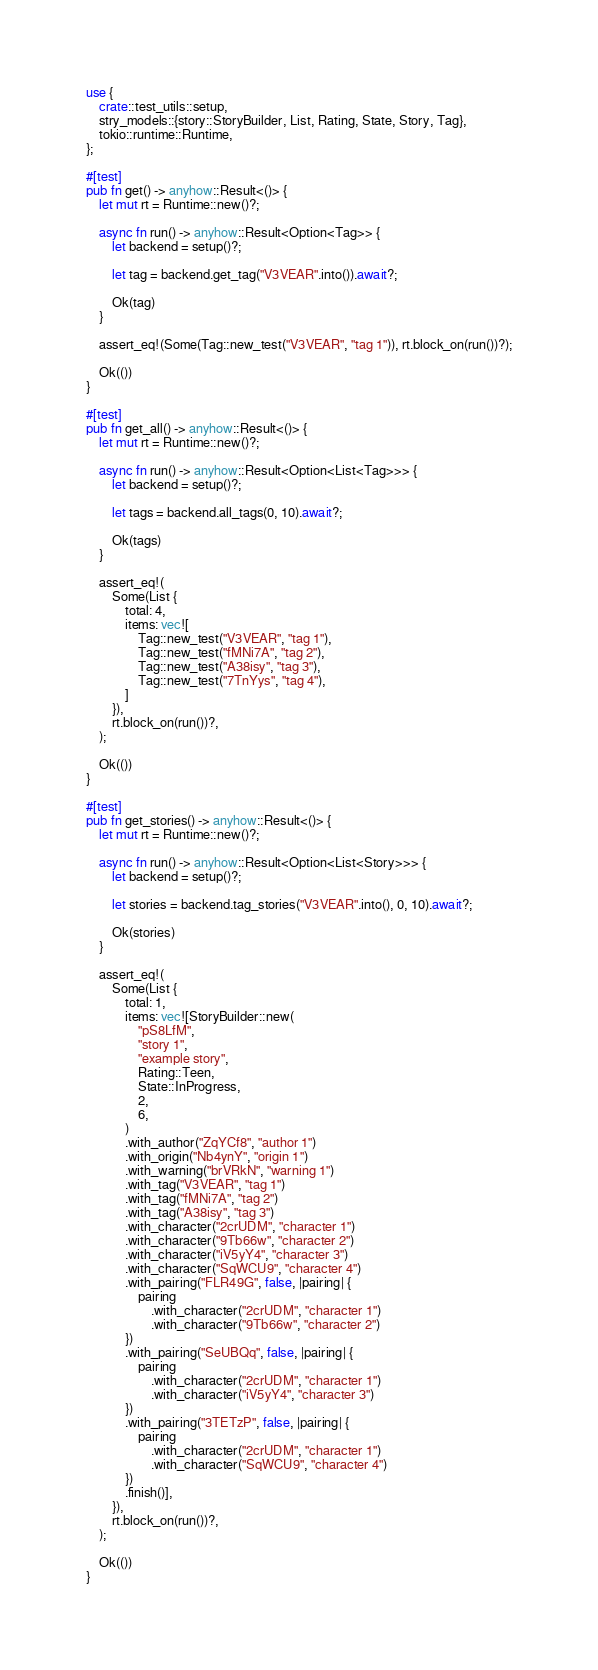<code> <loc_0><loc_0><loc_500><loc_500><_Rust_>use {
    crate::test_utils::setup,
    stry_models::{story::StoryBuilder, List, Rating, State, Story, Tag},
    tokio::runtime::Runtime,
};

#[test]
pub fn get() -> anyhow::Result<()> {
    let mut rt = Runtime::new()?;

    async fn run() -> anyhow::Result<Option<Tag>> {
        let backend = setup()?;

        let tag = backend.get_tag("V3VEAR".into()).await?;

        Ok(tag)
    }

    assert_eq!(Some(Tag::new_test("V3VEAR", "tag 1")), rt.block_on(run())?);

    Ok(())
}

#[test]
pub fn get_all() -> anyhow::Result<()> {
    let mut rt = Runtime::new()?;

    async fn run() -> anyhow::Result<Option<List<Tag>>> {
        let backend = setup()?;

        let tags = backend.all_tags(0, 10).await?;

        Ok(tags)
    }

    assert_eq!(
        Some(List {
            total: 4,
            items: vec![
                Tag::new_test("V3VEAR", "tag 1"),
                Tag::new_test("fMNi7A", "tag 2"),
                Tag::new_test("A38isy", "tag 3"),
                Tag::new_test("7TnYys", "tag 4"),
            ]
        }),
        rt.block_on(run())?,
    );

    Ok(())
}

#[test]
pub fn get_stories() -> anyhow::Result<()> {
    let mut rt = Runtime::new()?;

    async fn run() -> anyhow::Result<Option<List<Story>>> {
        let backend = setup()?;

        let stories = backend.tag_stories("V3VEAR".into(), 0, 10).await?;

        Ok(stories)
    }

    assert_eq!(
        Some(List {
            total: 1,
            items: vec![StoryBuilder::new(
                "pS8LfM",
                "story 1",
                "example story",
                Rating::Teen,
                State::InProgress,
                2,
                6,
            )
            .with_author("ZqYCf8", "author 1")
            .with_origin("Nb4ynY", "origin 1")
            .with_warning("brVRkN", "warning 1")
            .with_tag("V3VEAR", "tag 1")
            .with_tag("fMNi7A", "tag 2")
            .with_tag("A38isy", "tag 3")
            .with_character("2crUDM", "character 1")
            .with_character("9Tb66w", "character 2")
            .with_character("iV5yY4", "character 3")
            .with_character("SqWCU9", "character 4")
            .with_pairing("FLR49G", false, |pairing| {
                pairing
                    .with_character("2crUDM", "character 1")
                    .with_character("9Tb66w", "character 2")
            })
            .with_pairing("SeUBQq", false, |pairing| {
                pairing
                    .with_character("2crUDM", "character 1")
                    .with_character("iV5yY4", "character 3")
            })
            .with_pairing("3TETzP", false, |pairing| {
                pairing
                    .with_character("2crUDM", "character 1")
                    .with_character("SqWCU9", "character 4")
            })
            .finish()],
        }),
        rt.block_on(run())?,
    );

    Ok(())
}
</code> 